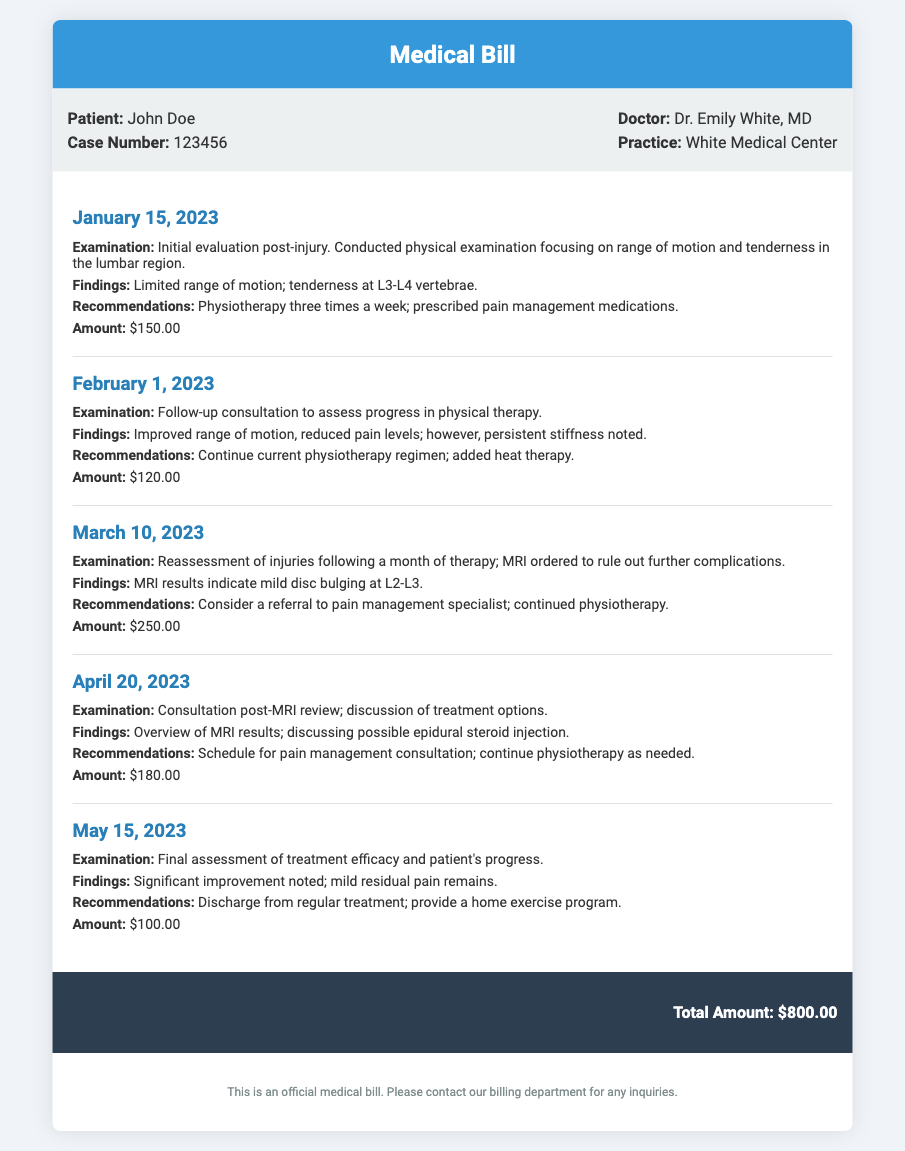What is the patient's name? The patient's name is mentioned at the top of the document under patient information.
Answer: John Doe What is the date of the initial evaluation? The date of the initial evaluation is specified in the consultation section as the first entry.
Answer: January 15, 2023 What was the recommendation on February 1, 2023? The recommendations are listed under each examination date in the consultations.
Answer: Continue current physiotherapy regimen; added heat therapy How much was charged for the consultation on March 10, 2023? The amount is clearly stated at the end of each consultation section.
Answer: $250.00 What were the findings mentioned on April 20, 2023? The findings summarizing the examination outcomes are included in the consultation details.
Answer: Overview of MRI results; discussing possible epidural steroid injection What is the total amount billed? The total amount is stated at the bottom of the document, summarizing all consultations.
Answer: $800.00 What type of examination was conducted on May 15, 2023? The type of examination is described in the consultation details under that date.
Answer: Final assessment of treatment efficacy and patient's progress How many times a week was physiotherapy recommended initially? The frequency for physiotherapy is mentioned in the first consultation's recommendations.
Answer: Three times a week What was noted during the February 1, 2023 consultation? Important observations from the consultation are detailed in the findings section for that date.
Answer: Improved range of motion, reduced pain levels; however, persistent stiffness noted 